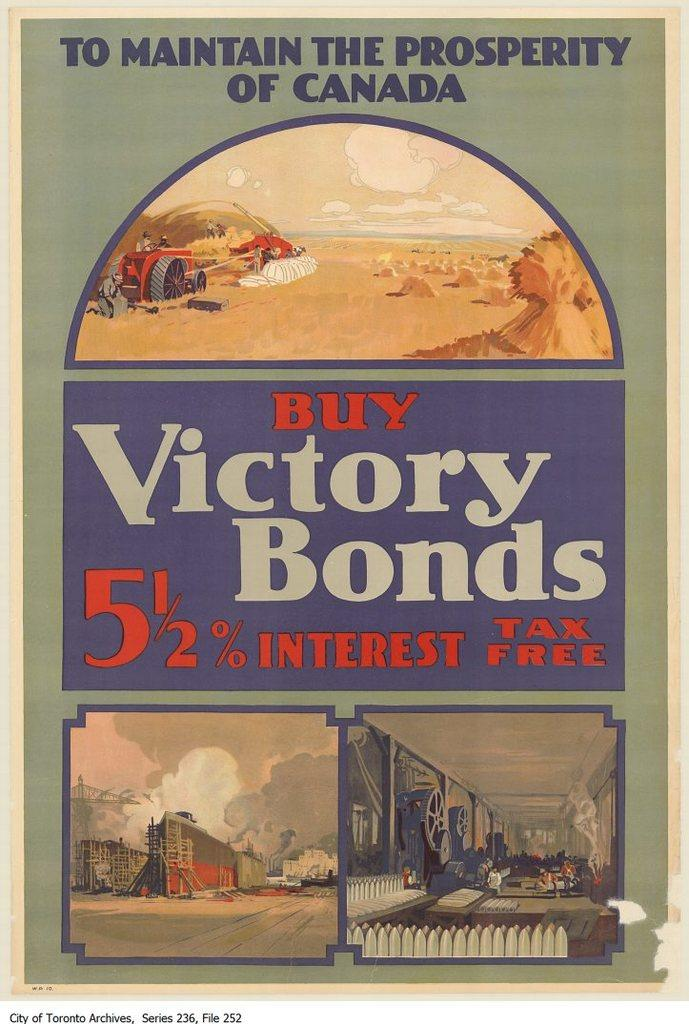<image>
Relay a brief, clear account of the picture shown. Cover for "To Maintain The Prosperity of Canada" showing people working. 